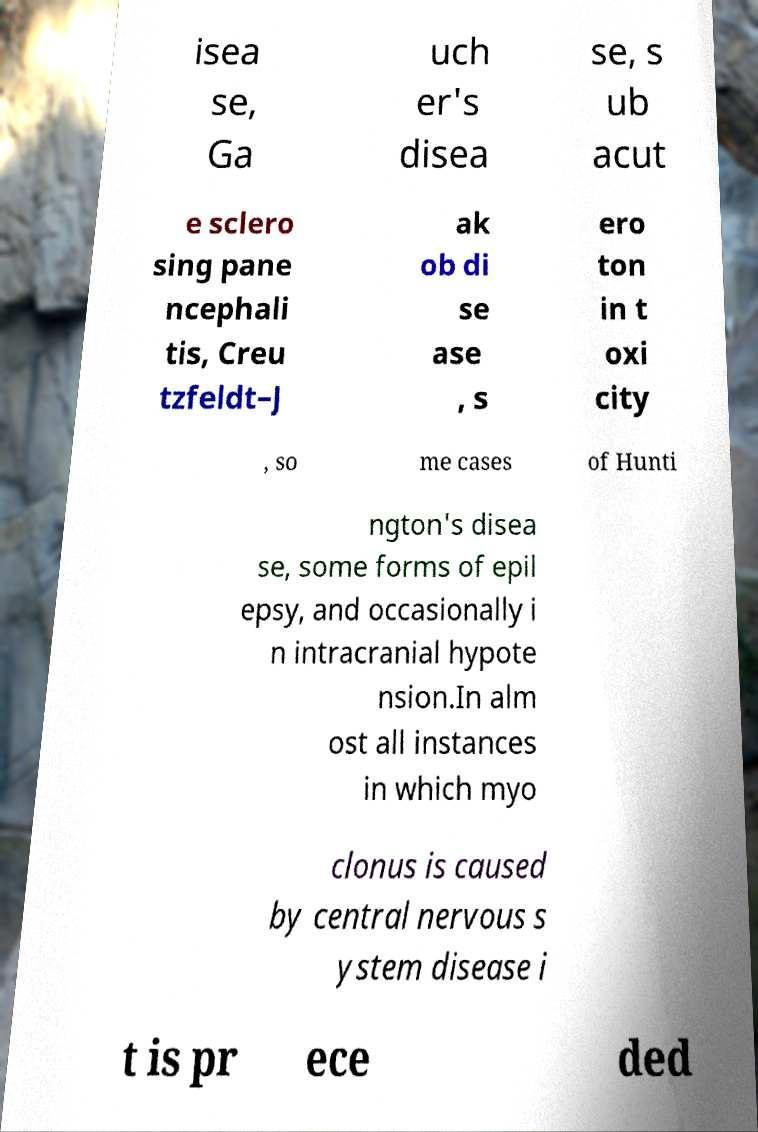What messages or text are displayed in this image? I need them in a readable, typed format. isea se, Ga uch er's disea se, s ub acut e sclero sing pane ncephali tis, Creu tzfeldt–J ak ob di se ase , s ero ton in t oxi city , so me cases of Hunti ngton's disea se, some forms of epil epsy, and occasionally i n intracranial hypote nsion.In alm ost all instances in which myo clonus is caused by central nervous s ystem disease i t is pr ece ded 